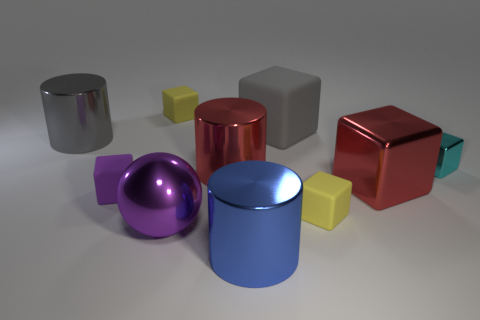Can you tell which object is largest based on this image? It appears that the red block is the largest object, though perspective could be a factor. If all blocks and cylinders are placed equidistantly from the viewpoint, the red block would indeed be the largest. 